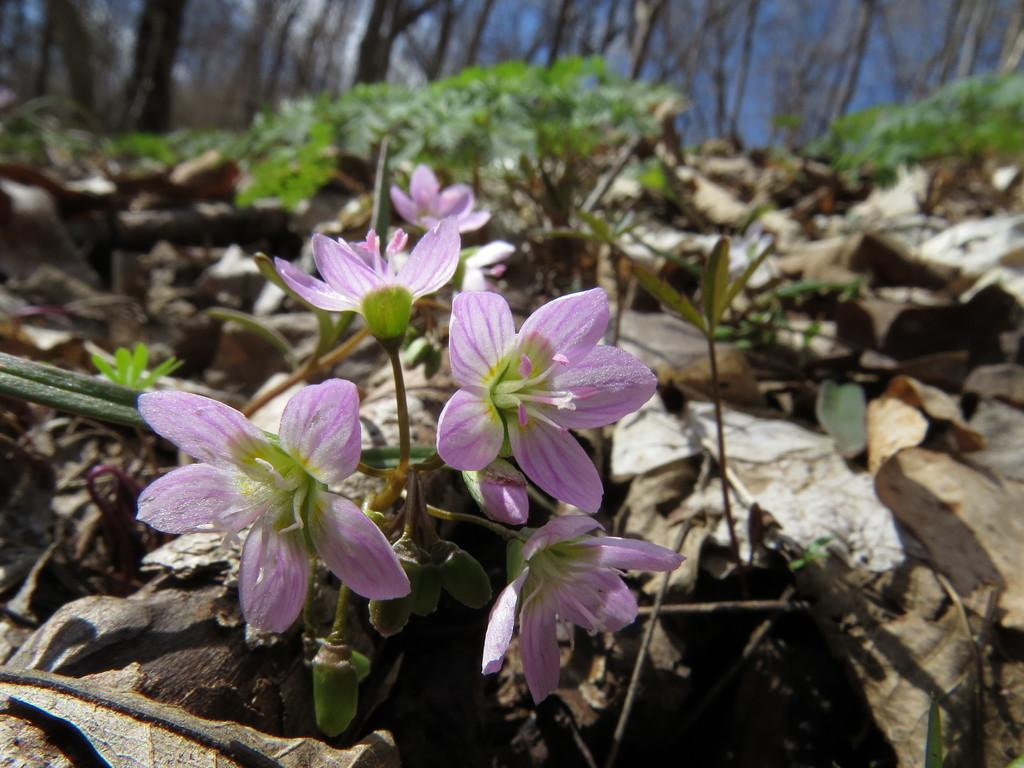What can be seen in the foreground of the picture? There are flowers, dry leaves, and plants in the foreground of the picture. How would you describe the background of the image? The background of the image is blurred. What type of vegetation is visible in the background of the picture? There are trees in the background of the image. What is the weather like in the image? The sky is sunny, indicating a clear and bright day. What type of flesh can be seen hanging from the trees in the image? There is no flesh present in the image; it features flowers, dry leaves, plants, and trees. Can you tell me how the cart is being controlled in the image? There is no cart present in the image. 